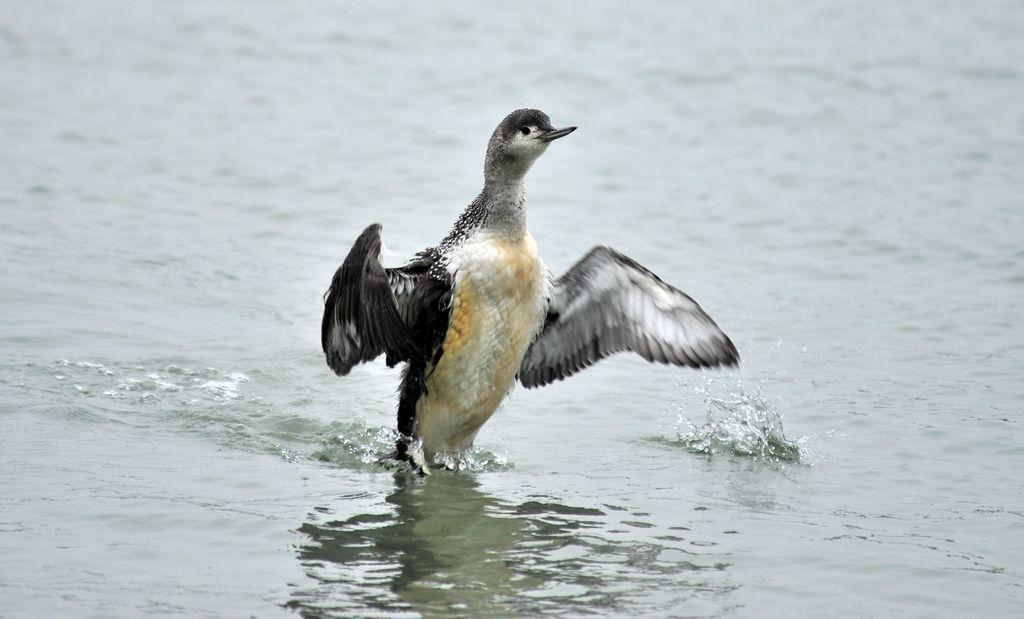What animal can be seen in the image? There is a bird in the image. Where is the bird located? The bird is on the water. In which direction is the bird facing? The bird is facing towards the right side. What type of mask is the bird wearing in the image? There is no mask present on the bird in the image. Is there a box visible in the image? No, there is no box present in the image. 